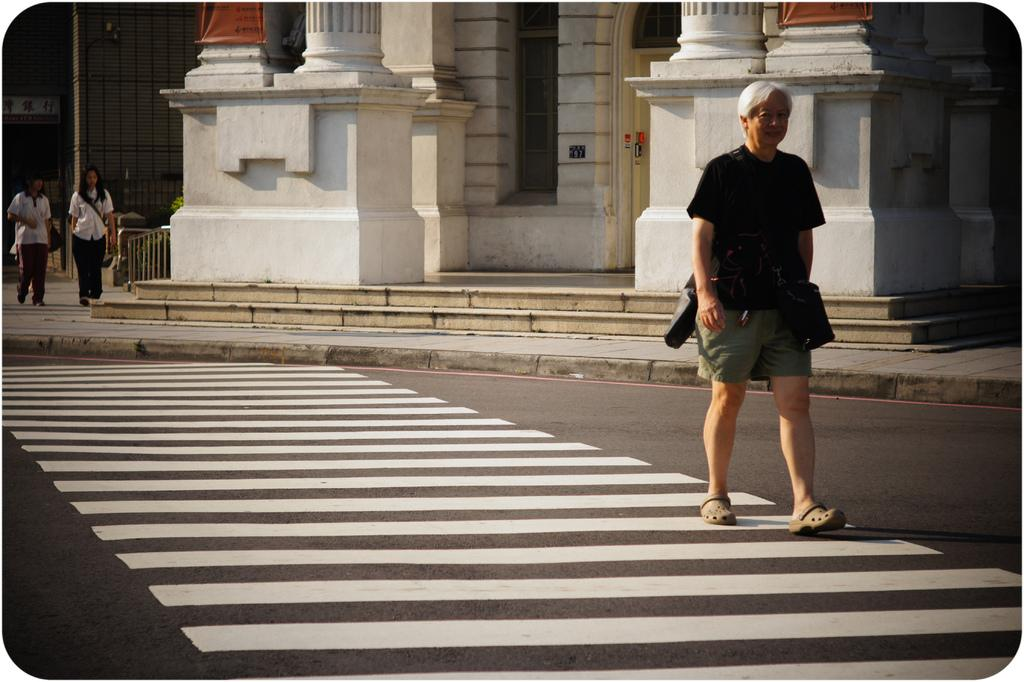What is the main subject of the image? There is a person walking on the pathway. What can be seen in the background of the image? There are people standing in the background and a building. Can you describe the building in the background? The building has windows, pillars, a staircase, and a fence. How many goldfish are swimming in the fountain in the image? There is no fountain or goldfish present in the image. 